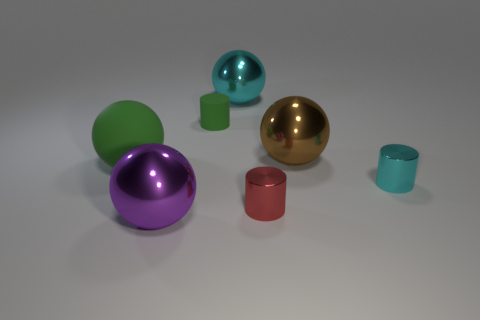Does the lighting in the image suggest a particular time of day? The lighting in the image appears to be diffuse and neutral, suggesting an indoor setting with controlled lighting rather than natural sunlight. Therefore, it does not indicate a specific time of day but rather an environment typically found in a studio or indoor setting. 